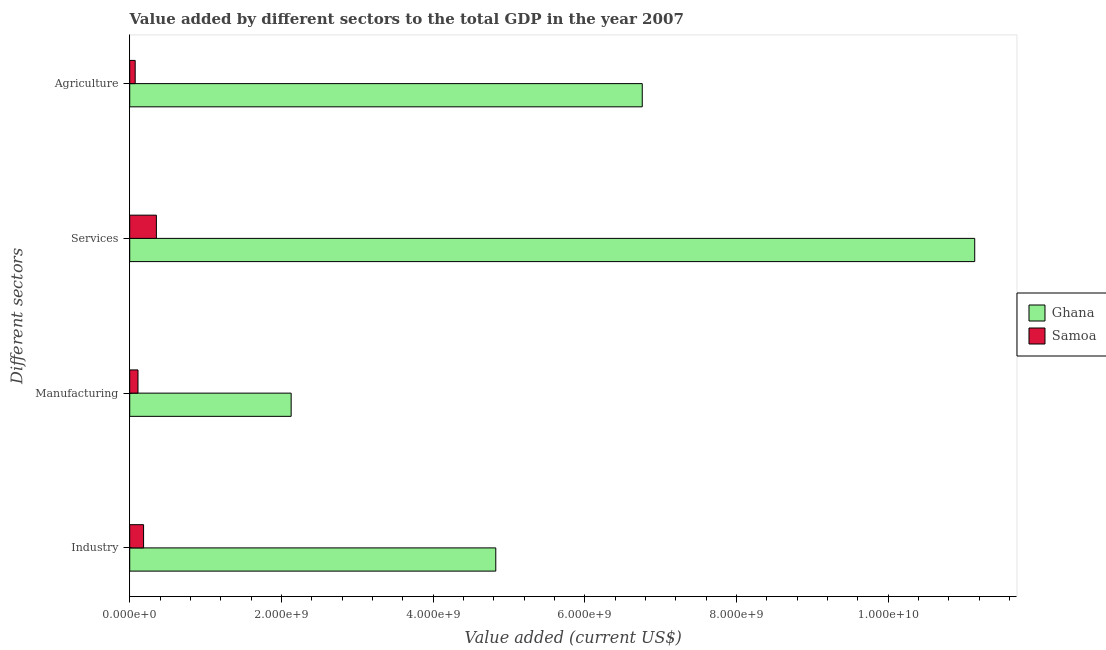How many different coloured bars are there?
Your answer should be very brief. 2. How many groups of bars are there?
Your answer should be compact. 4. Are the number of bars per tick equal to the number of legend labels?
Make the answer very short. Yes. How many bars are there on the 2nd tick from the bottom?
Make the answer very short. 2. What is the label of the 2nd group of bars from the top?
Make the answer very short. Services. What is the value added by industrial sector in Samoa?
Make the answer very short. 1.83e+08. Across all countries, what is the maximum value added by industrial sector?
Your response must be concise. 4.83e+09. Across all countries, what is the minimum value added by services sector?
Ensure brevity in your answer.  3.51e+08. In which country was the value added by manufacturing sector maximum?
Your response must be concise. Ghana. In which country was the value added by manufacturing sector minimum?
Keep it short and to the point. Samoa. What is the total value added by agricultural sector in the graph?
Ensure brevity in your answer.  6.83e+09. What is the difference between the value added by industrial sector in Samoa and that in Ghana?
Your answer should be compact. -4.64e+09. What is the difference between the value added by services sector in Samoa and the value added by manufacturing sector in Ghana?
Ensure brevity in your answer.  -1.78e+09. What is the average value added by agricultural sector per country?
Make the answer very short. 3.41e+09. What is the difference between the value added by industrial sector and value added by manufacturing sector in Ghana?
Keep it short and to the point. 2.70e+09. What is the ratio of the value added by industrial sector in Ghana to that in Samoa?
Your answer should be compact. 26.42. What is the difference between the highest and the second highest value added by industrial sector?
Offer a very short reply. 4.64e+09. What is the difference between the highest and the lowest value added by agricultural sector?
Provide a succinct answer. 6.69e+09. In how many countries, is the value added by services sector greater than the average value added by services sector taken over all countries?
Give a very brief answer. 1. Is the sum of the value added by manufacturing sector in Samoa and Ghana greater than the maximum value added by industrial sector across all countries?
Make the answer very short. No. What does the 1st bar from the top in Services represents?
Keep it short and to the point. Samoa. Where does the legend appear in the graph?
Keep it short and to the point. Center right. How are the legend labels stacked?
Provide a short and direct response. Vertical. What is the title of the graph?
Offer a very short reply. Value added by different sectors to the total GDP in the year 2007. Does "Bolivia" appear as one of the legend labels in the graph?
Provide a succinct answer. No. What is the label or title of the X-axis?
Your answer should be very brief. Value added (current US$). What is the label or title of the Y-axis?
Offer a very short reply. Different sectors. What is the Value added (current US$) of Ghana in Industry?
Offer a very short reply. 4.83e+09. What is the Value added (current US$) in Samoa in Industry?
Your response must be concise. 1.83e+08. What is the Value added (current US$) of Ghana in Manufacturing?
Your response must be concise. 2.13e+09. What is the Value added (current US$) in Samoa in Manufacturing?
Your answer should be very brief. 1.09e+08. What is the Value added (current US$) in Ghana in Services?
Your response must be concise. 1.11e+1. What is the Value added (current US$) of Samoa in Services?
Your answer should be very brief. 3.51e+08. What is the Value added (current US$) in Ghana in Agriculture?
Provide a succinct answer. 6.76e+09. What is the Value added (current US$) in Samoa in Agriculture?
Your answer should be compact. 7.20e+07. Across all Different sectors, what is the maximum Value added (current US$) of Ghana?
Your response must be concise. 1.11e+1. Across all Different sectors, what is the maximum Value added (current US$) of Samoa?
Your answer should be very brief. 3.51e+08. Across all Different sectors, what is the minimum Value added (current US$) in Ghana?
Ensure brevity in your answer.  2.13e+09. Across all Different sectors, what is the minimum Value added (current US$) of Samoa?
Provide a short and direct response. 7.20e+07. What is the total Value added (current US$) in Ghana in the graph?
Make the answer very short. 2.49e+1. What is the total Value added (current US$) in Samoa in the graph?
Ensure brevity in your answer.  7.15e+08. What is the difference between the Value added (current US$) in Ghana in Industry and that in Manufacturing?
Your answer should be compact. 2.70e+09. What is the difference between the Value added (current US$) of Samoa in Industry and that in Manufacturing?
Your response must be concise. 7.38e+07. What is the difference between the Value added (current US$) of Ghana in Industry and that in Services?
Make the answer very short. -6.31e+09. What is the difference between the Value added (current US$) of Samoa in Industry and that in Services?
Your answer should be compact. -1.69e+08. What is the difference between the Value added (current US$) in Ghana in Industry and that in Agriculture?
Your response must be concise. -1.93e+09. What is the difference between the Value added (current US$) in Samoa in Industry and that in Agriculture?
Your answer should be compact. 1.11e+08. What is the difference between the Value added (current US$) in Ghana in Manufacturing and that in Services?
Provide a short and direct response. -9.01e+09. What is the difference between the Value added (current US$) in Samoa in Manufacturing and that in Services?
Provide a succinct answer. -2.43e+08. What is the difference between the Value added (current US$) of Ghana in Manufacturing and that in Agriculture?
Provide a succinct answer. -4.63e+09. What is the difference between the Value added (current US$) in Samoa in Manufacturing and that in Agriculture?
Provide a short and direct response. 3.69e+07. What is the difference between the Value added (current US$) in Ghana in Services and that in Agriculture?
Provide a succinct answer. 4.38e+09. What is the difference between the Value added (current US$) in Samoa in Services and that in Agriculture?
Make the answer very short. 2.79e+08. What is the difference between the Value added (current US$) in Ghana in Industry and the Value added (current US$) in Samoa in Manufacturing?
Your response must be concise. 4.72e+09. What is the difference between the Value added (current US$) of Ghana in Industry and the Value added (current US$) of Samoa in Services?
Offer a very short reply. 4.47e+09. What is the difference between the Value added (current US$) in Ghana in Industry and the Value added (current US$) in Samoa in Agriculture?
Offer a terse response. 4.75e+09. What is the difference between the Value added (current US$) in Ghana in Manufacturing and the Value added (current US$) in Samoa in Services?
Give a very brief answer. 1.78e+09. What is the difference between the Value added (current US$) in Ghana in Manufacturing and the Value added (current US$) in Samoa in Agriculture?
Your response must be concise. 2.06e+09. What is the difference between the Value added (current US$) in Ghana in Services and the Value added (current US$) in Samoa in Agriculture?
Your response must be concise. 1.11e+1. What is the average Value added (current US$) in Ghana per Different sectors?
Offer a terse response. 6.21e+09. What is the average Value added (current US$) in Samoa per Different sectors?
Make the answer very short. 1.79e+08. What is the difference between the Value added (current US$) of Ghana and Value added (current US$) of Samoa in Industry?
Make the answer very short. 4.64e+09. What is the difference between the Value added (current US$) of Ghana and Value added (current US$) of Samoa in Manufacturing?
Your answer should be compact. 2.02e+09. What is the difference between the Value added (current US$) in Ghana and Value added (current US$) in Samoa in Services?
Your answer should be compact. 1.08e+1. What is the difference between the Value added (current US$) of Ghana and Value added (current US$) of Samoa in Agriculture?
Make the answer very short. 6.69e+09. What is the ratio of the Value added (current US$) in Ghana in Industry to that in Manufacturing?
Make the answer very short. 2.27. What is the ratio of the Value added (current US$) in Samoa in Industry to that in Manufacturing?
Give a very brief answer. 1.68. What is the ratio of the Value added (current US$) in Ghana in Industry to that in Services?
Your response must be concise. 0.43. What is the ratio of the Value added (current US$) of Samoa in Industry to that in Services?
Provide a succinct answer. 0.52. What is the ratio of the Value added (current US$) of Ghana in Industry to that in Agriculture?
Your response must be concise. 0.71. What is the ratio of the Value added (current US$) of Samoa in Industry to that in Agriculture?
Offer a very short reply. 2.54. What is the ratio of the Value added (current US$) of Ghana in Manufacturing to that in Services?
Offer a terse response. 0.19. What is the ratio of the Value added (current US$) in Samoa in Manufacturing to that in Services?
Provide a succinct answer. 0.31. What is the ratio of the Value added (current US$) in Ghana in Manufacturing to that in Agriculture?
Provide a succinct answer. 0.32. What is the ratio of the Value added (current US$) of Samoa in Manufacturing to that in Agriculture?
Your response must be concise. 1.51. What is the ratio of the Value added (current US$) of Ghana in Services to that in Agriculture?
Provide a short and direct response. 1.65. What is the ratio of the Value added (current US$) in Samoa in Services to that in Agriculture?
Your response must be concise. 4.88. What is the difference between the highest and the second highest Value added (current US$) of Ghana?
Your response must be concise. 4.38e+09. What is the difference between the highest and the second highest Value added (current US$) in Samoa?
Give a very brief answer. 1.69e+08. What is the difference between the highest and the lowest Value added (current US$) in Ghana?
Offer a very short reply. 9.01e+09. What is the difference between the highest and the lowest Value added (current US$) of Samoa?
Offer a terse response. 2.79e+08. 